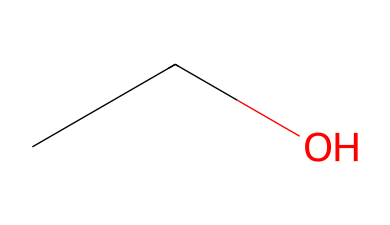What is the name of the chemical represented by this SMILES? The SMILES "CCO" corresponds to ethanol, which is a simple alcohol with two carbon atoms and is commonly used as an antiseptic in hand sanitizers.
Answer: ethanol How many carbon atoms are present in this chemical? The SMILES representation "CCO" indicates two carbon atoms, as each "C" corresponds to one carbon atom in the structure.
Answer: two What is the basic functional group of this chemical? The presence of the "-OH" group in ethanol indicates that it contains a hydroxyl functional group, characteristic of alcohols.
Answer: hydroxyl Is this chemical classified as a volatile liquid? Ethanol has a low boiling point compared to many substances, making it volatile and able to evaporate quickly at room temperature.
Answer: yes What is the molecular formula of this chemical? Analyzing the structure reveals two carbon atoms, six hydrogen atoms, and one oxygen atom, leading to the molecular formula C2H6O.
Answer: C2H6O Does this chemical have flammable properties? Ethanol is known to be flammable due to its ability to ignite easily and burn when exposed to an open flame or high heat.
Answer: yes How many hydrogen atoms are in this chemical? The structure "CCO" indicates six hydrogen atoms in total, as each carbon atom can bond to enough hydrogen atoms to satisfy the basic tetravalency rule.
Answer: six 